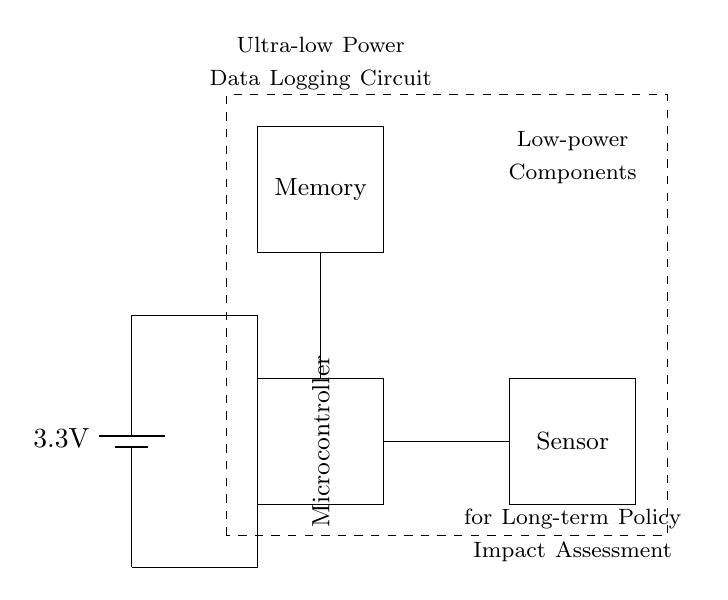What is the power source used in the circuit? The circuit uses a 3.3V battery as the power source, which is indicated at the top of the diagram.
Answer: 3.3V battery What component is located at the center of the circuit? The microcontroller is positioned in the center of the diagram, representing the main processing unit for the circuit.
Answer: Microcontroller How many primary components are identified in the circuit? There are three primary components: a microcontroller, a sensor, and memory which are all labeled accordingly in the circuit.
Answer: Three Why is the low-power functionality important for this circuit? Low-power functionality is crucial for long-term data logging applications, ensuring the device can operate for extended periods without frequent battery replacements, supporting a sustainable data collection strategy.
Answer: Long-term operation What type of memory is used in the circuit? The diagram does not specify the type of memory but indicates that memory is part of the circuit, ensuring data is stored for logging purposes.
Answer: Memory (type not specified) How do the components connect to each other? The components are connected through wires; power is fed from the battery to the microcontroller and memory, while the sensor also connects to the microcontroller for data acquisition, forming a clear flow of information.
Answer: Through wires What does the dashed rectangle represent in the circuit? The dashed rectangle encloses low-power components, indicating that the whole system is designed to minimize power usage effectively, which is critical for applications requiring extended operational time.
Answer: Low-power components 